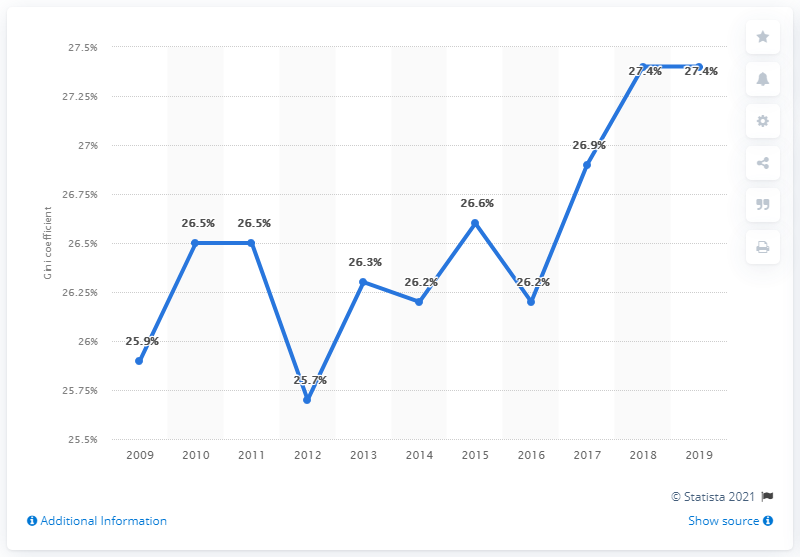Draw attention to some important aspects in this diagram. In 2019, Finland's Gini coefficient was 27.4, indicating a moderate level of income inequality. 